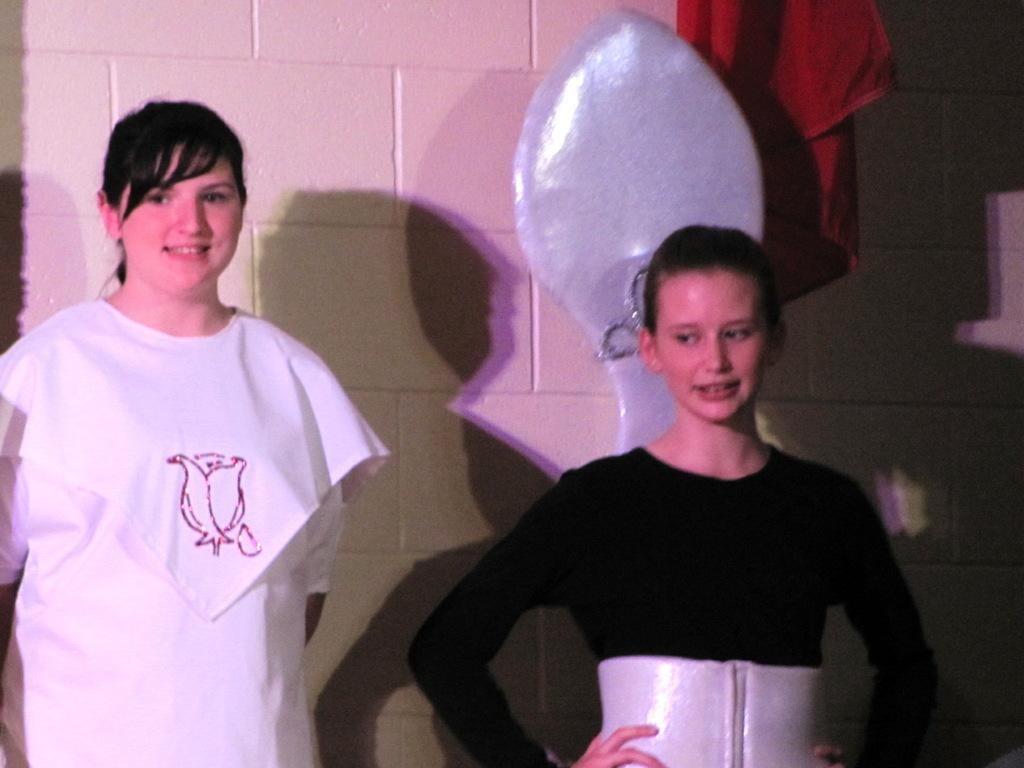How many people are in the image? There are two persons in the image. What are the persons doing in the image? The persons are standing. What are the persons wearing in the image? The persons are wearing costumes. What can be seen in the background of the image? There is a wall in the background of the image. What type of material is visible in the image? There is a cloth visible in the image. What type of plane can be seen flying in the image? There is no plane visible in the image; it only features two persons standing and wearing costumes, a wall in the background, and a cloth. 